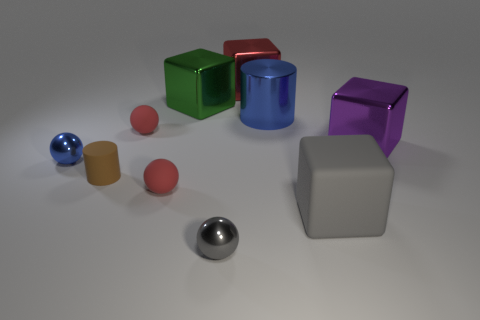Are there any large blue things behind the green block?
Give a very brief answer. No. Do the gray block and the purple metallic block have the same size?
Offer a very short reply. Yes. What shape is the small metal object that is behind the small gray metal thing?
Provide a short and direct response. Sphere. Are there any rubber cylinders of the same size as the green block?
Provide a short and direct response. No. There is a blue object that is the same size as the brown matte object; what is it made of?
Offer a terse response. Metal. There is a metallic ball that is in front of the tiny brown cylinder; how big is it?
Your response must be concise. Small. What is the size of the purple metal thing?
Give a very brief answer. Large. There is a purple shiny object; does it have the same size as the red thing that is in front of the small blue sphere?
Offer a terse response. No. What is the color of the big block that is in front of the blue object to the left of the big red metallic object?
Ensure brevity in your answer.  Gray. Are there an equal number of tiny red things in front of the red metal object and large green cubes in front of the purple shiny cube?
Keep it short and to the point. No. 